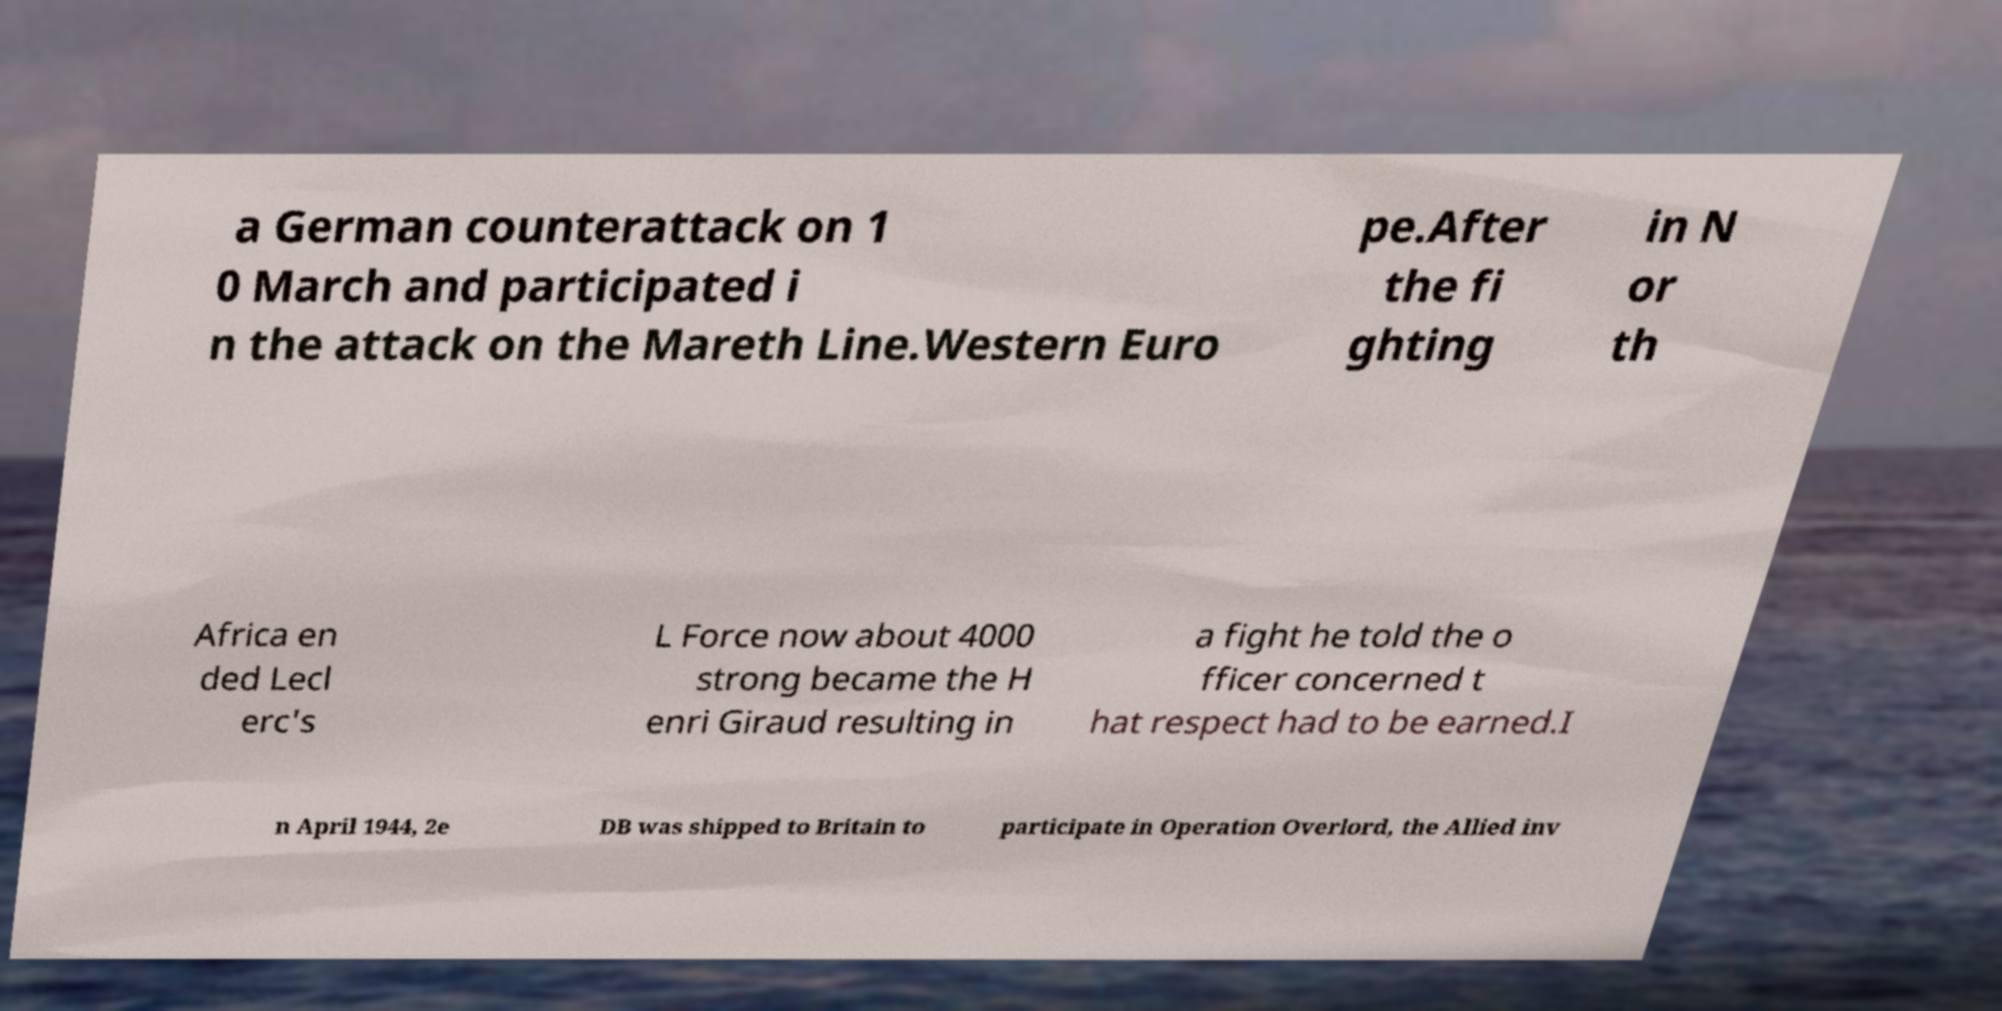For documentation purposes, I need the text within this image transcribed. Could you provide that? a German counterattack on 1 0 March and participated i n the attack on the Mareth Line.Western Euro pe.After the fi ghting in N or th Africa en ded Lecl erc's L Force now about 4000 strong became the H enri Giraud resulting in a fight he told the o fficer concerned t hat respect had to be earned.I n April 1944, 2e DB was shipped to Britain to participate in Operation Overlord, the Allied inv 